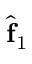Convert formula to latex. <formula><loc_0><loc_0><loc_500><loc_500>\hat { f } _ { 1 }</formula> 